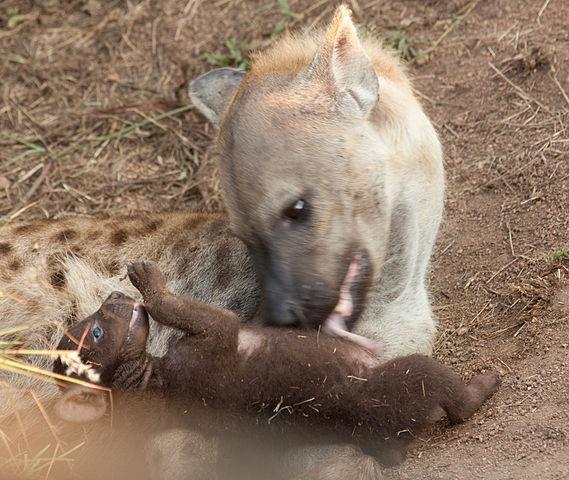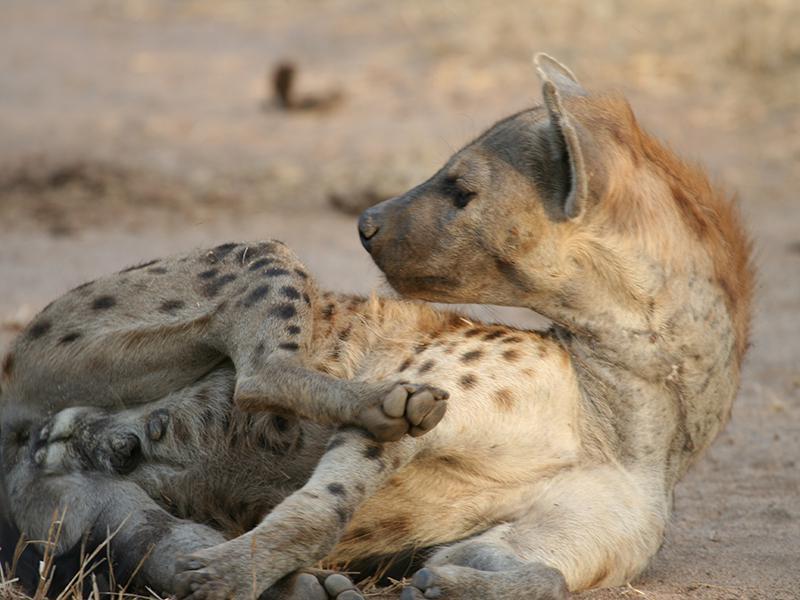The first image is the image on the left, the second image is the image on the right. Examine the images to the left and right. Is the description "Each image features one hyena with distinctive spotted fur, and the hyena on the left has its head turned around, while the hyena on the right reclines with its front paws extended." accurate? Answer yes or no. No. The first image is the image on the left, the second image is the image on the right. Analyze the images presented: Is the assertion "There is a single adult hyena in each image, but they are looking in opposite directions." valid? Answer yes or no. No. 